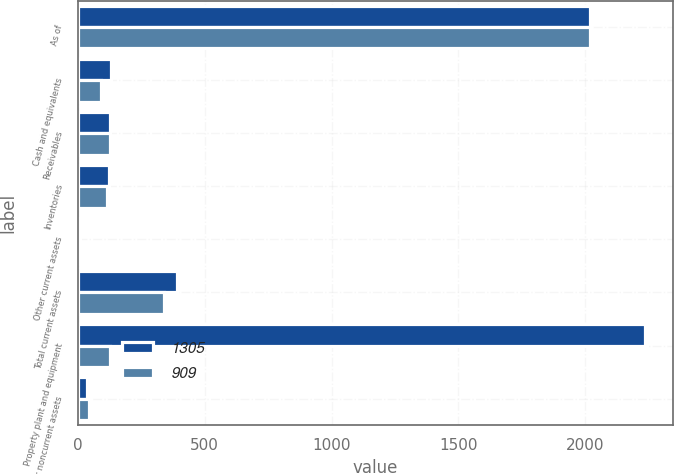<chart> <loc_0><loc_0><loc_500><loc_500><stacked_bar_chart><ecel><fcel>As of<fcel>Cash and equivalents<fcel>Receivables<fcel>Inventories<fcel>Other current assets<fcel>Total current assets<fcel>Property plant and equipment<fcel>Other noncurrent assets<nl><fcel>1305<fcel>2019<fcel>130<fcel>128<fcel>124<fcel>9<fcel>391<fcel>2235<fcel>38<nl><fcel>909<fcel>2018<fcel>91<fcel>126<fcel>114<fcel>8<fcel>339<fcel>126<fcel>45<nl></chart> 